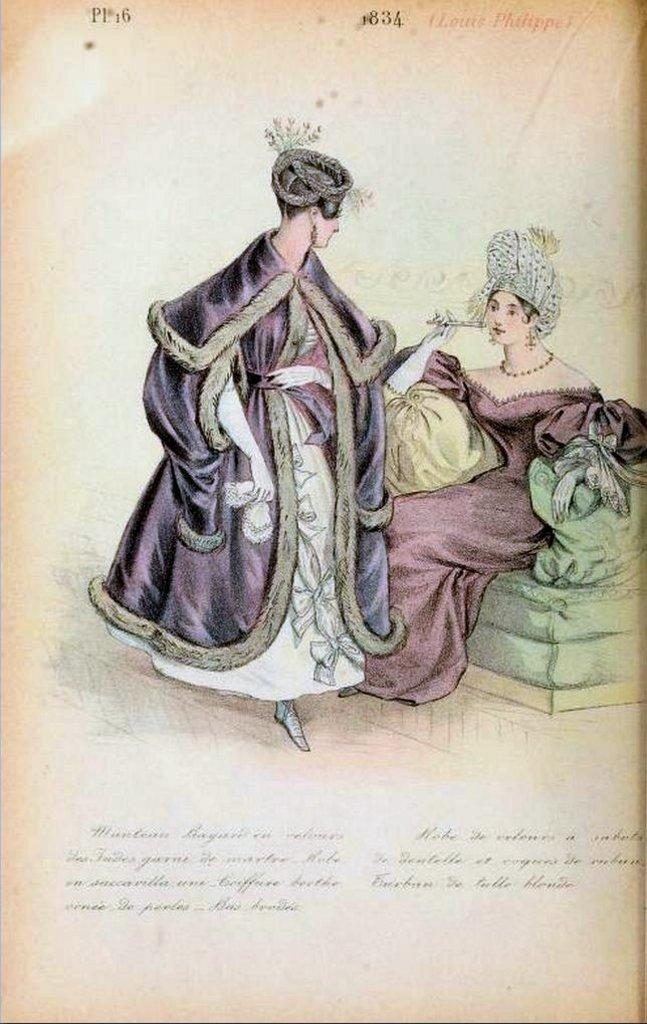Can you describe this image briefly? It is a page from some book,in the picture there are two women and both of them looking like princesses,one of the woman is sitting on a sofa and another one is standing beside her. 